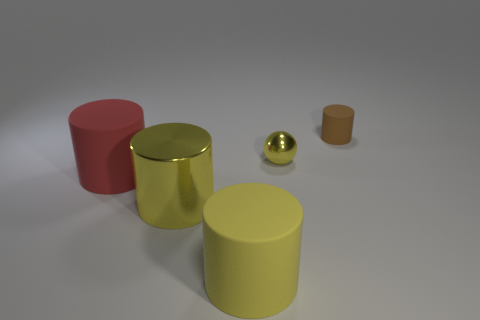What number of small yellow things have the same material as the small yellow ball?
Offer a very short reply. 0. How many tiny brown matte things are left of the big yellow metal cylinder?
Make the answer very short. 0. Is the small thing on the left side of the small brown thing made of the same material as the cylinder that is behind the big red cylinder?
Give a very brief answer. No. Are there more yellow metal cylinders behind the tiny cylinder than large red objects that are behind the red thing?
Offer a very short reply. No. What is the material of the tiny object that is the same color as the metal cylinder?
Ensure brevity in your answer.  Metal. Is there anything else that has the same shape as the large yellow shiny thing?
Provide a short and direct response. Yes. There is a thing that is on the right side of the big metallic cylinder and in front of the yellow shiny ball; what material is it?
Offer a very short reply. Rubber. Do the large red object and the large yellow cylinder to the left of the yellow rubber thing have the same material?
Give a very brief answer. No. Is there anything else that is the same size as the metal cylinder?
Your response must be concise. Yes. How many things are either red objects or rubber things left of the brown cylinder?
Make the answer very short. 2. 